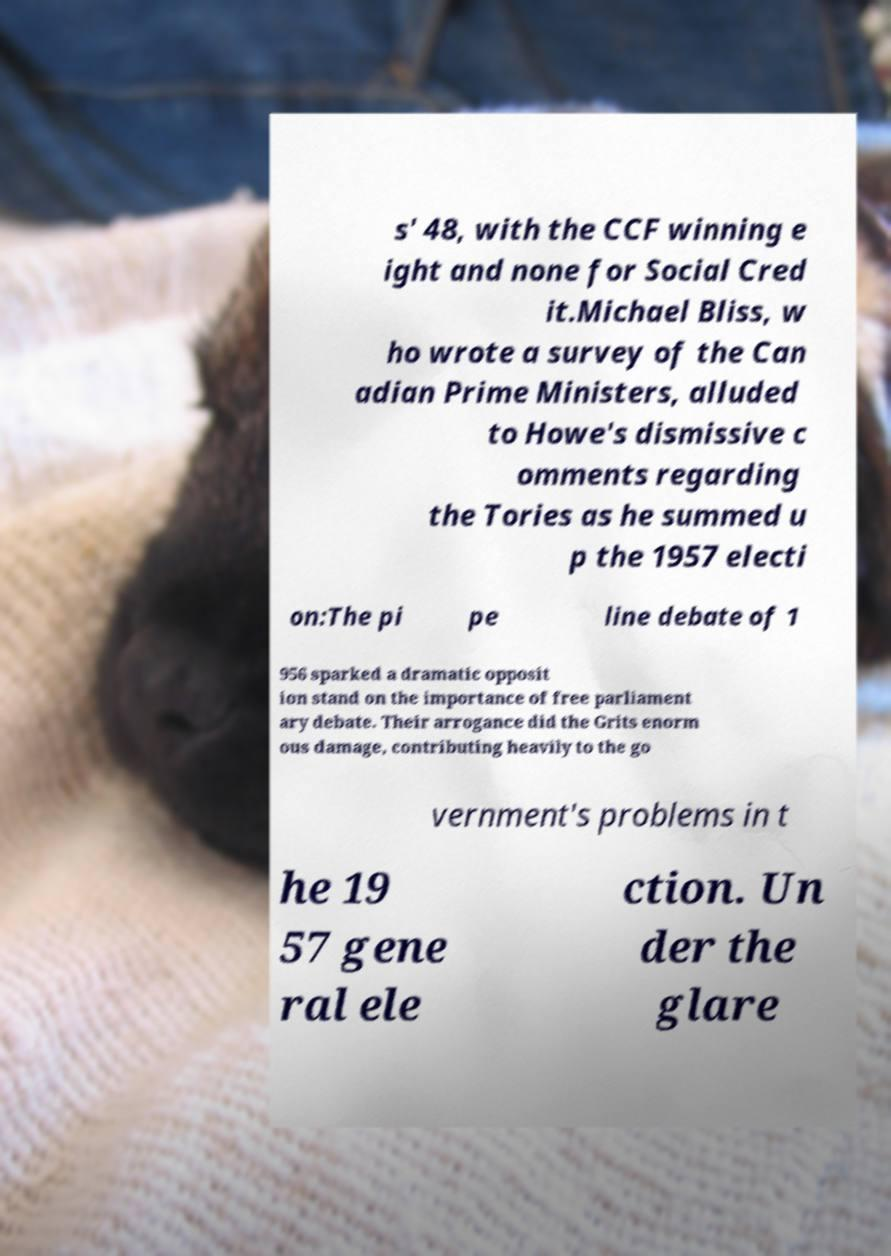Please read and relay the text visible in this image. What does it say? s' 48, with the CCF winning e ight and none for Social Cred it.Michael Bliss, w ho wrote a survey of the Can adian Prime Ministers, alluded to Howe's dismissive c omments regarding the Tories as he summed u p the 1957 electi on:The pi pe line debate of 1 956 sparked a dramatic opposit ion stand on the importance of free parliament ary debate. Their arrogance did the Grits enorm ous damage, contributing heavily to the go vernment's problems in t he 19 57 gene ral ele ction. Un der the glare 